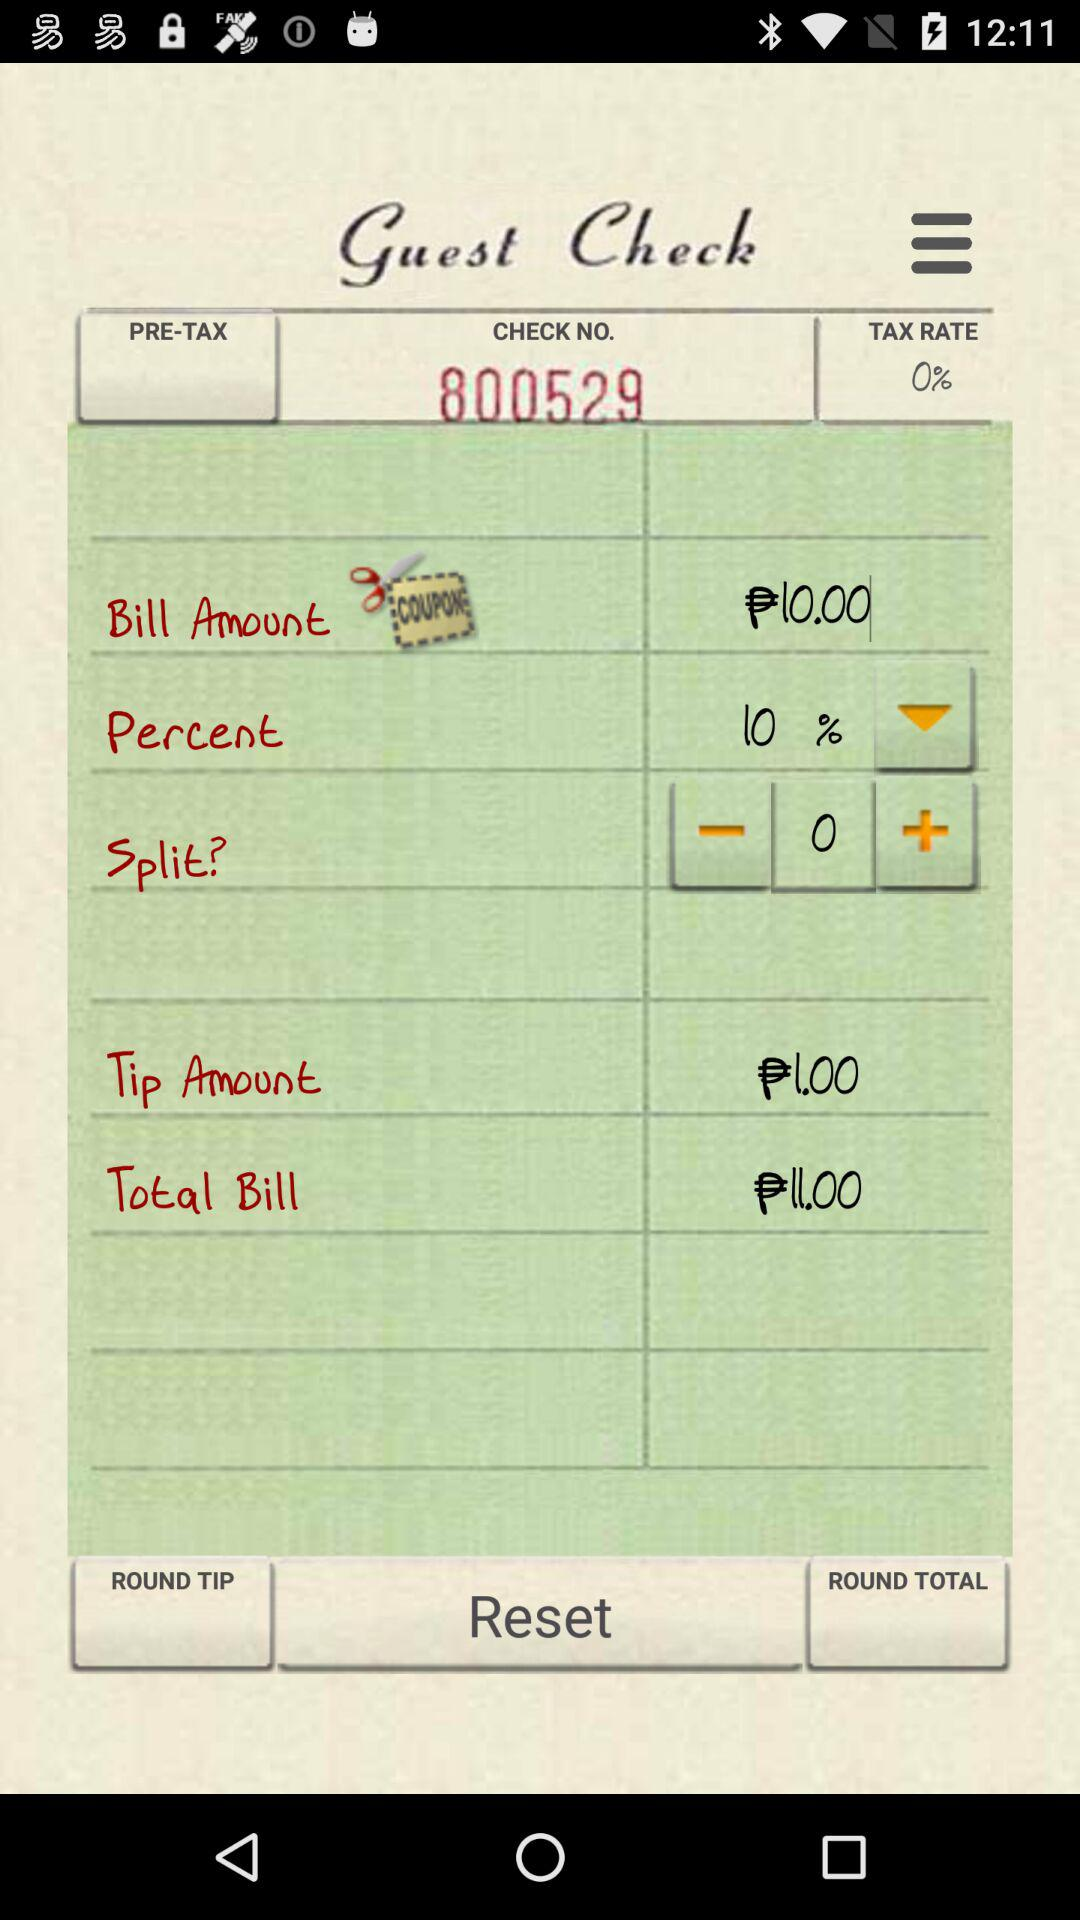What is the total bill? The total bill is ₱11.00. 